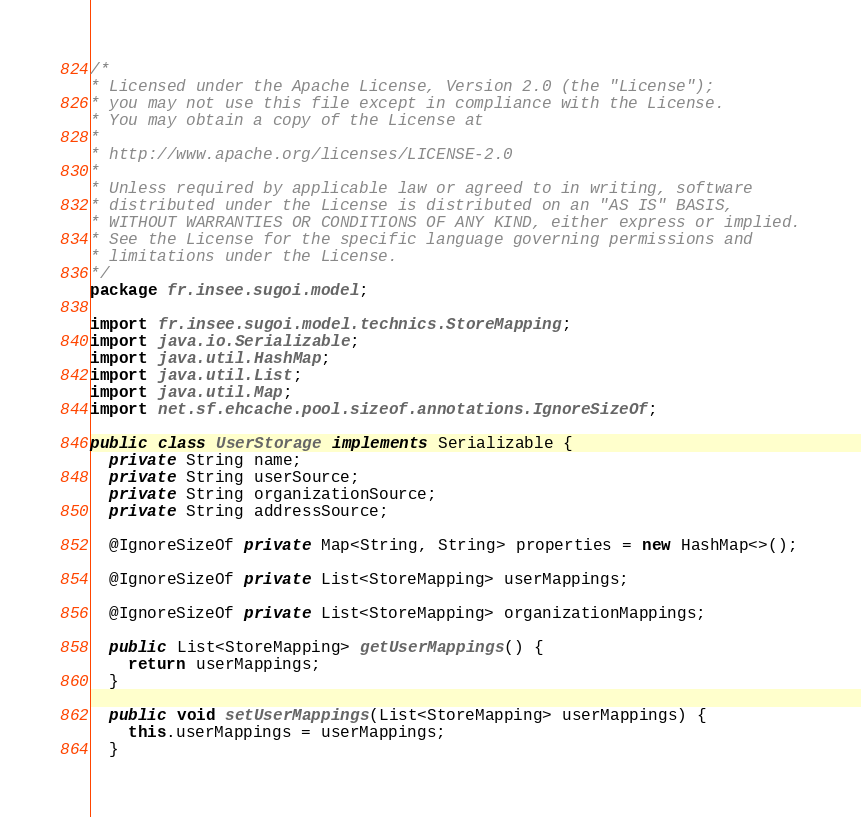<code> <loc_0><loc_0><loc_500><loc_500><_Java_>/*
* Licensed under the Apache License, Version 2.0 (the "License");
* you may not use this file except in compliance with the License.
* You may obtain a copy of the License at
*
* http://www.apache.org/licenses/LICENSE-2.0
*
* Unless required by applicable law or agreed to in writing, software
* distributed under the License is distributed on an "AS IS" BASIS,
* WITHOUT WARRANTIES OR CONDITIONS OF ANY KIND, either express or implied.
* See the License for the specific language governing permissions and
* limitations under the License.
*/
package fr.insee.sugoi.model;

import fr.insee.sugoi.model.technics.StoreMapping;
import java.io.Serializable;
import java.util.HashMap;
import java.util.List;
import java.util.Map;
import net.sf.ehcache.pool.sizeof.annotations.IgnoreSizeOf;

public class UserStorage implements Serializable {
  private String name;
  private String userSource;
  private String organizationSource;
  private String addressSource;

  @IgnoreSizeOf private Map<String, String> properties = new HashMap<>();

  @IgnoreSizeOf private List<StoreMapping> userMappings;

  @IgnoreSizeOf private List<StoreMapping> organizationMappings;

  public List<StoreMapping> getUserMappings() {
    return userMappings;
  }

  public void setUserMappings(List<StoreMapping> userMappings) {
    this.userMappings = userMappings;
  }
</code> 